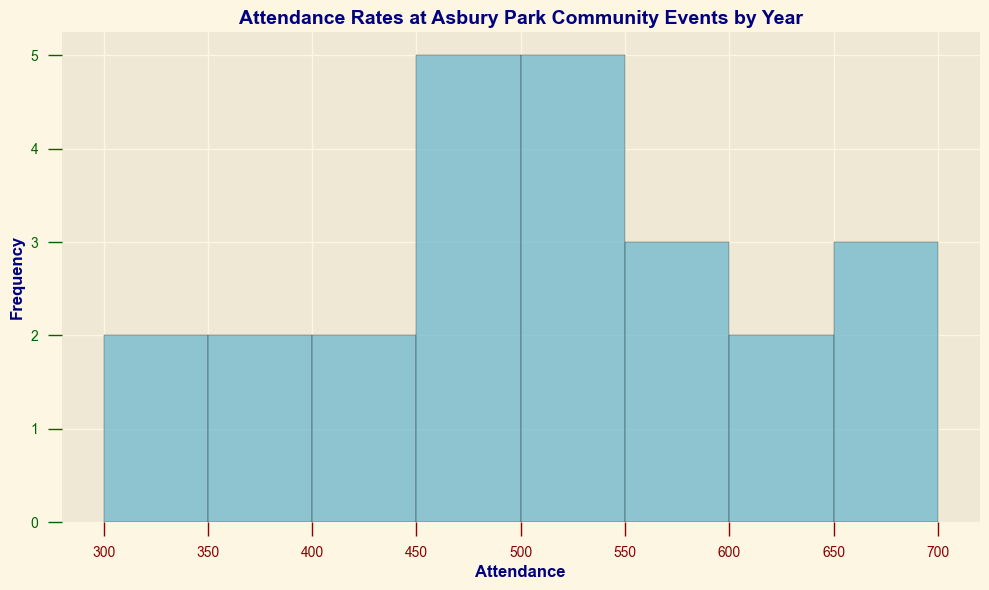What's the most frequent attendance range at Asbury Park Community Events? By visually inspecting the histogram, we see which bar is the tallest, indicating the most frequent attendance range. In this case, the tallest bar is in the range of 450-500 attendees.
Answer: 450-500 Which year had the lowest attendance at community events? To find this, look for the bar that represents the lowest count in the histogram. The year with the lowest attendance is 2020, as it has a bar in the lower attendance range (300-350) and no bars in higher ranges compared to other years.
Answer: 2020 What's the range with the highest frequency of attendance between 500 and 600? To determine this, identify the bar heights within the 500-600 range on the histogram. The tallest bars within this range are in the bins of 500-550 and 550-600 attendees.
Answer: 500-550 and 550-600 How many different attendance bins have more than three events occurring in them? Count the number of bins that have a bar height indicating more than three occurrences. In the histogram, there are three bins (450-500, 500-550, 550-600) that have bars higher than the line for three events.
Answer: Three bins What's the typical attendance range for the most recent year of data? Review the part of the histogram that represents the most recent years, focusing on 2022. The histogram shows bars in the 550-600, and 650-700 ranges for 2022, with the taller bar in the 550-600 range.
Answer: 550-600 How many bins have an attendance count of exactly 500? Look for bins where the attendance value ranges around 500 and check the heights of the bars. The bin from 450-500 includes 500, and it has more than three events, but the question asks for occurrences of **exactly** 500, which is visually not directly countable from the histogram without exact data points being marked. Thus another standard inspection may be needed for such a specific count
Answer: Data not precise for exact count but can be deduced from bins inclusion Compare the attendance ranges: Which has a higher frequency, 400-450 or 300-350? By visually comparing the heights of the bars for the attendance ranges 400-450 and 300-350 on the histogram, it’s clear that the 300-350 range has a higher bar, indicating a higher frequency.
Answer: 300-350 What is the most dense range of attendance (most bins with significant counts close to full capacity)? To determine density, look for clustered tall bars visually. Bins in the range 450-500, 500-550, and 550-600 have consistently high bar heights indicating significant counts and are closely packed. This makes the 450-600 range densely populated.
Answer: 450-600 Was there any year with all event attendance consistently above 500? To answer this, observe whether any part of the histogram shows no bars below 500 for any year. No year shows such a pattern; the events of all years include some bins below 500.
Answer: No 